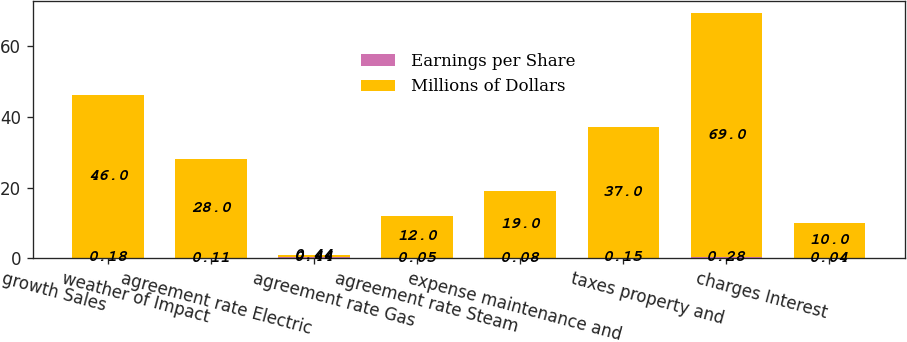<chart> <loc_0><loc_0><loc_500><loc_500><stacked_bar_chart><ecel><fcel>growth Sales<fcel>weather of Impact<fcel>agreement rate Electric<fcel>agreement rate Gas<fcel>agreement rate Steam<fcel>expense maintenance and<fcel>taxes property and<fcel>charges Interest<nl><fcel>Earnings per Share<fcel>0.18<fcel>0.11<fcel>0.44<fcel>0.05<fcel>0.08<fcel>0.15<fcel>0.28<fcel>0.04<nl><fcel>Millions of Dollars<fcel>46<fcel>28<fcel>0.44<fcel>12<fcel>19<fcel>37<fcel>69<fcel>10<nl></chart> 